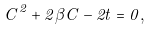<formula> <loc_0><loc_0><loc_500><loc_500>C ^ { 2 } + 2 \beta C - 2 t = 0 ,</formula> 